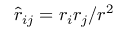Convert formula to latex. <formula><loc_0><loc_0><loc_500><loc_500>\hat { r } _ { i j } = r _ { i } r _ { j } / r ^ { 2 }</formula> 